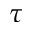Convert formula to latex. <formula><loc_0><loc_0><loc_500><loc_500>\tau</formula> 